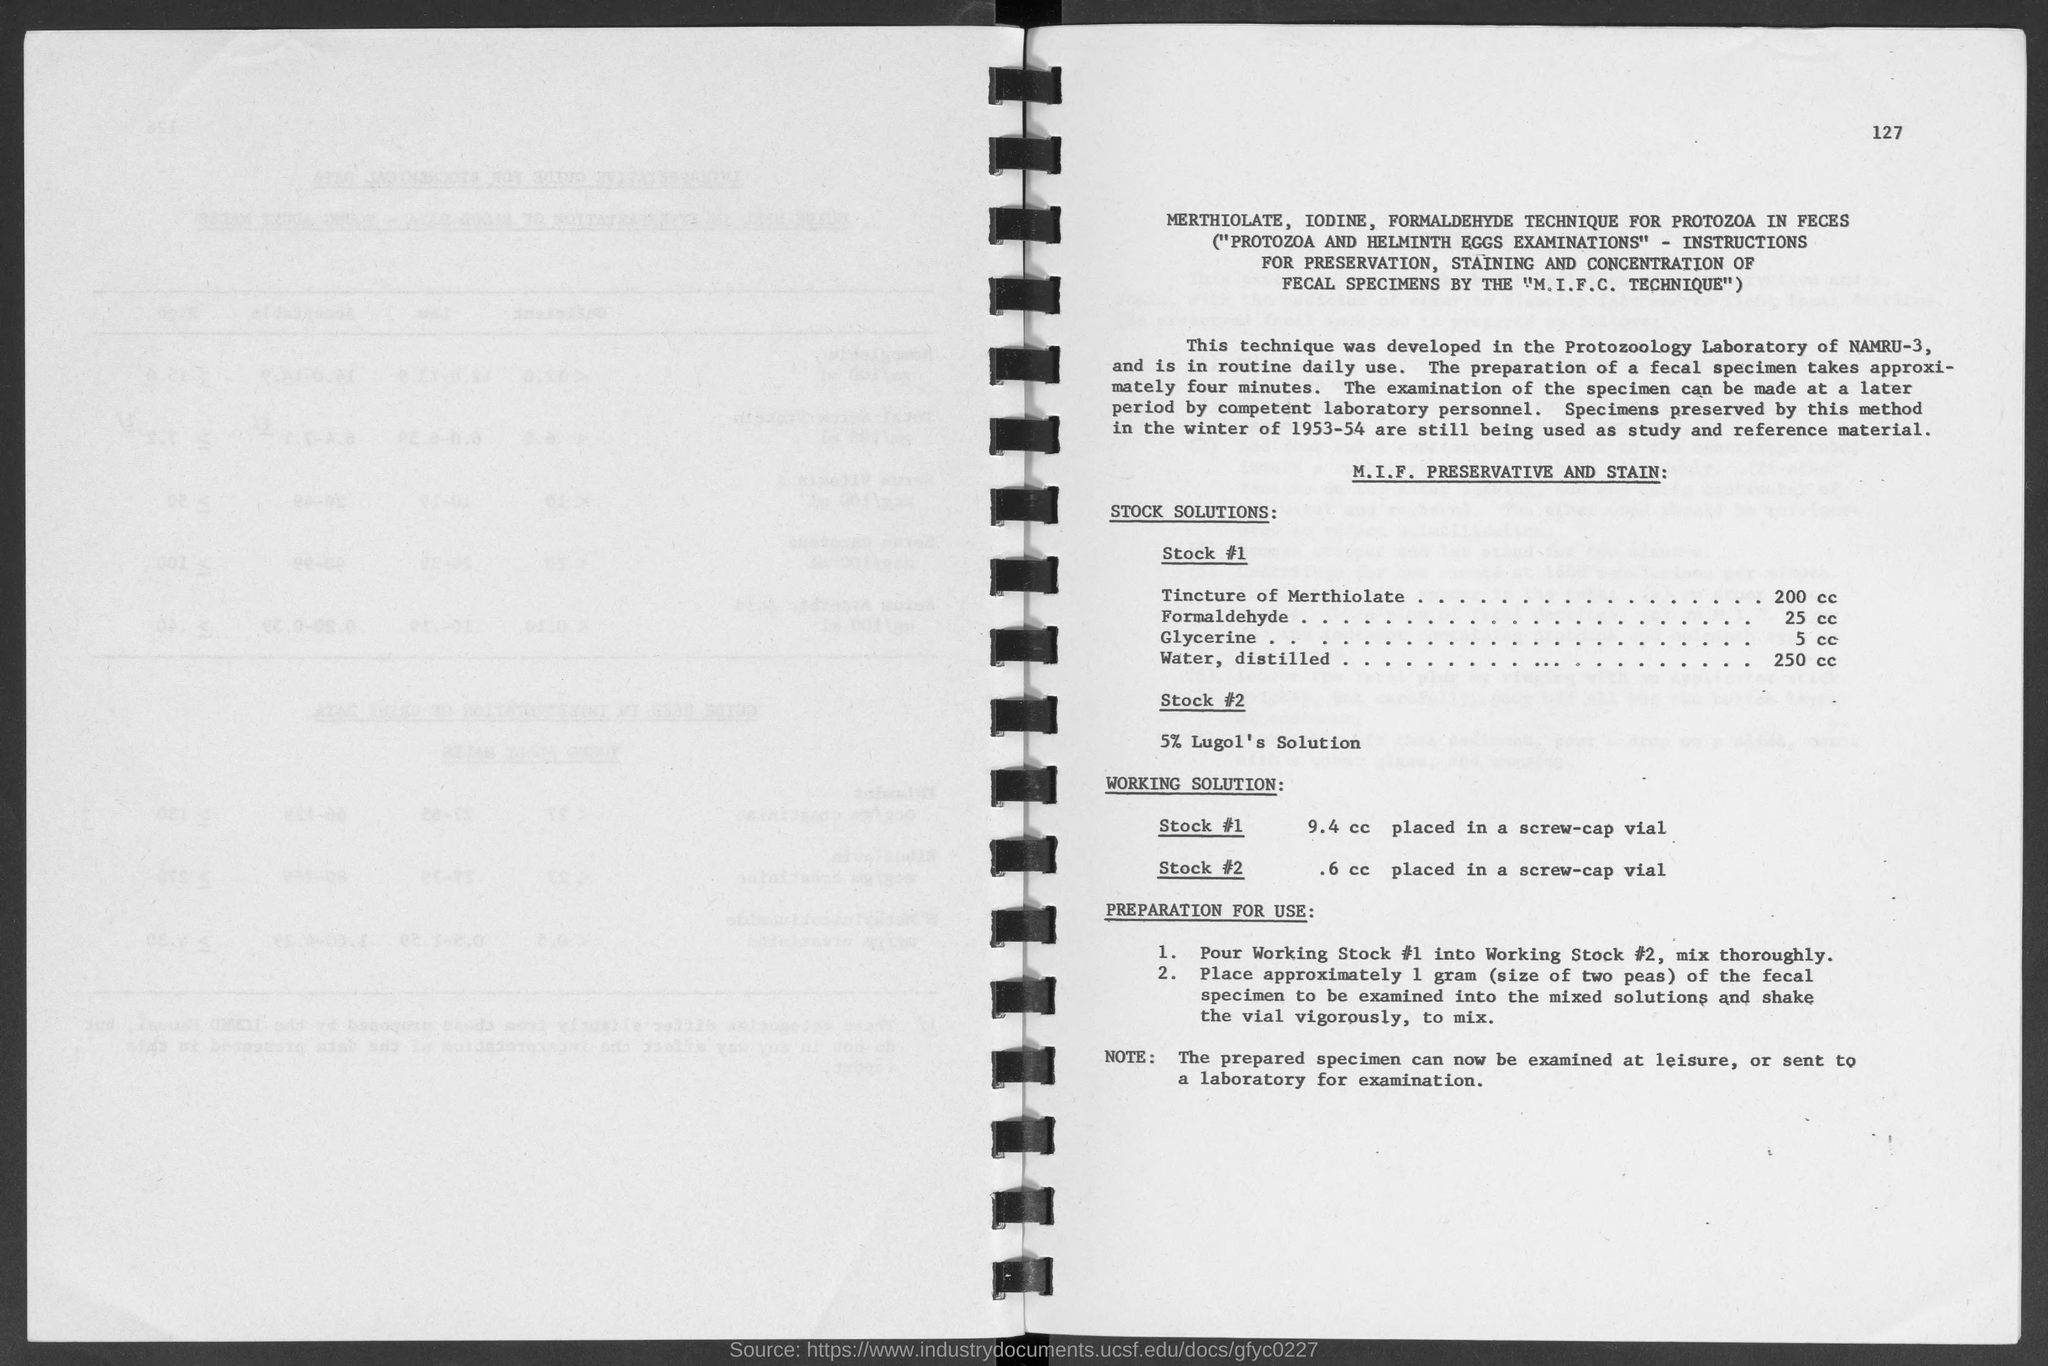What is the number at top-right corner of the page?
Your response must be concise. 127. What is the amount of tincture of merthiolate in stock#1?
Make the answer very short. 200 cc. What is the amount of formaldehyde in stock #1?
Your answer should be compact. 25 cc. What is the amount of glycerine in  stock#1?
Your answer should be very brief. 5 cc. What is the amount of water, distilled ?
Give a very brief answer. 250 cc. 